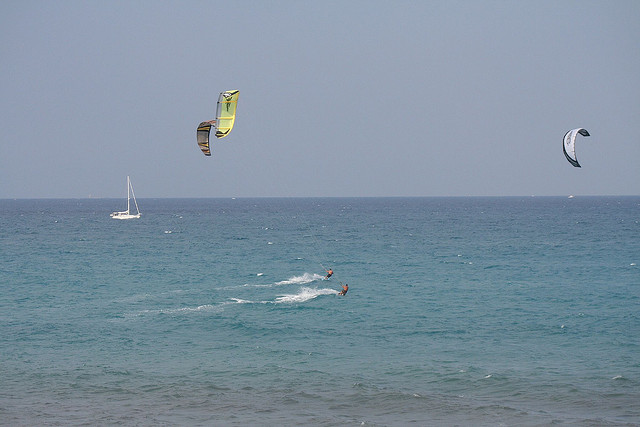If I were to participate in this activity, what safety precautions should I consider? If you were to participate in kite surfing, you should consider the following safety precautions: ensure your equipment is in good condition, check weather and wind conditions, wear a life jacket, know your limits and skill level, and always surf with a buddy or in areas with lifeguard supervision. 